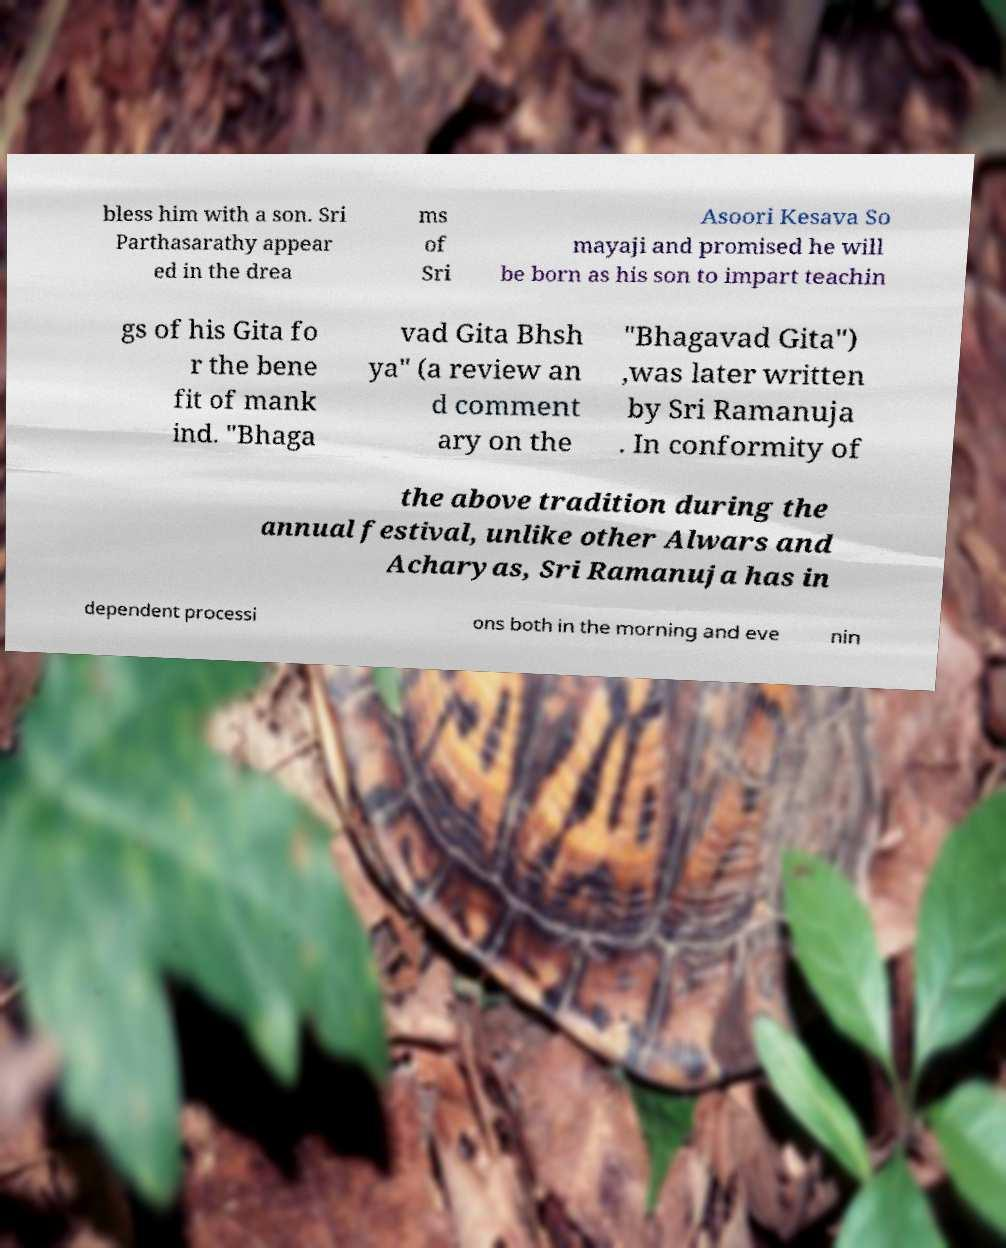Could you assist in decoding the text presented in this image and type it out clearly? bless him with a son. Sri Parthasarathy appear ed in the drea ms of Sri Asoori Kesava So mayaji and promised he will be born as his son to impart teachin gs of his Gita fo r the bene fit of mank ind. "Bhaga vad Gita Bhsh ya" (a review an d comment ary on the "Bhagavad Gita") ,was later written by Sri Ramanuja . In conformity of the above tradition during the annual festival, unlike other Alwars and Acharyas, Sri Ramanuja has in dependent processi ons both in the morning and eve nin 